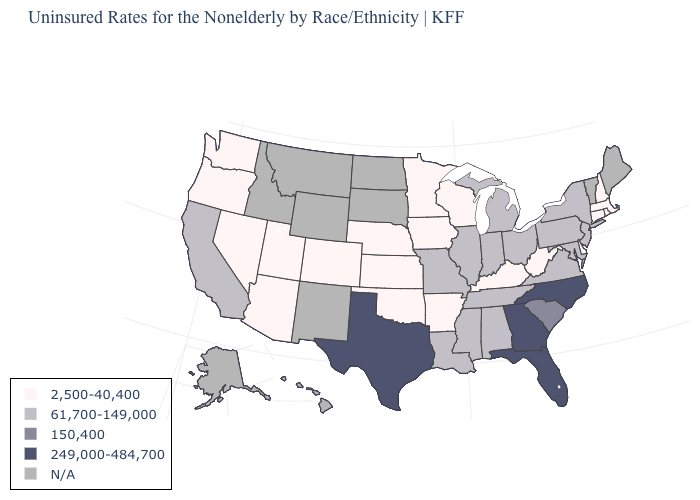Does Florida have the highest value in the USA?
Quick response, please. Yes. What is the value of Pennsylvania?
Keep it brief. 61,700-149,000. Which states have the lowest value in the Northeast?
Concise answer only. Connecticut, Massachusetts, New Hampshire, Rhode Island. Name the states that have a value in the range 249,000-484,700?
Quick response, please. Florida, Georgia, North Carolina, Texas. Name the states that have a value in the range N/A?
Answer briefly. Alaska, Hawaii, Idaho, Maine, Montana, New Mexico, North Dakota, South Dakota, Vermont, Wyoming. Name the states that have a value in the range 150,400?
Write a very short answer. South Carolina. Is the legend a continuous bar?
Short answer required. No. What is the value of Massachusetts?
Give a very brief answer. 2,500-40,400. What is the lowest value in states that border Illinois?
Be succinct. 2,500-40,400. Is the legend a continuous bar?
Write a very short answer. No. What is the highest value in states that border Maryland?
Give a very brief answer. 61,700-149,000. Name the states that have a value in the range 249,000-484,700?
Quick response, please. Florida, Georgia, North Carolina, Texas. What is the value of Connecticut?
Give a very brief answer. 2,500-40,400. What is the value of Iowa?
Write a very short answer. 2,500-40,400. Name the states that have a value in the range N/A?
Be succinct. Alaska, Hawaii, Idaho, Maine, Montana, New Mexico, North Dakota, South Dakota, Vermont, Wyoming. 